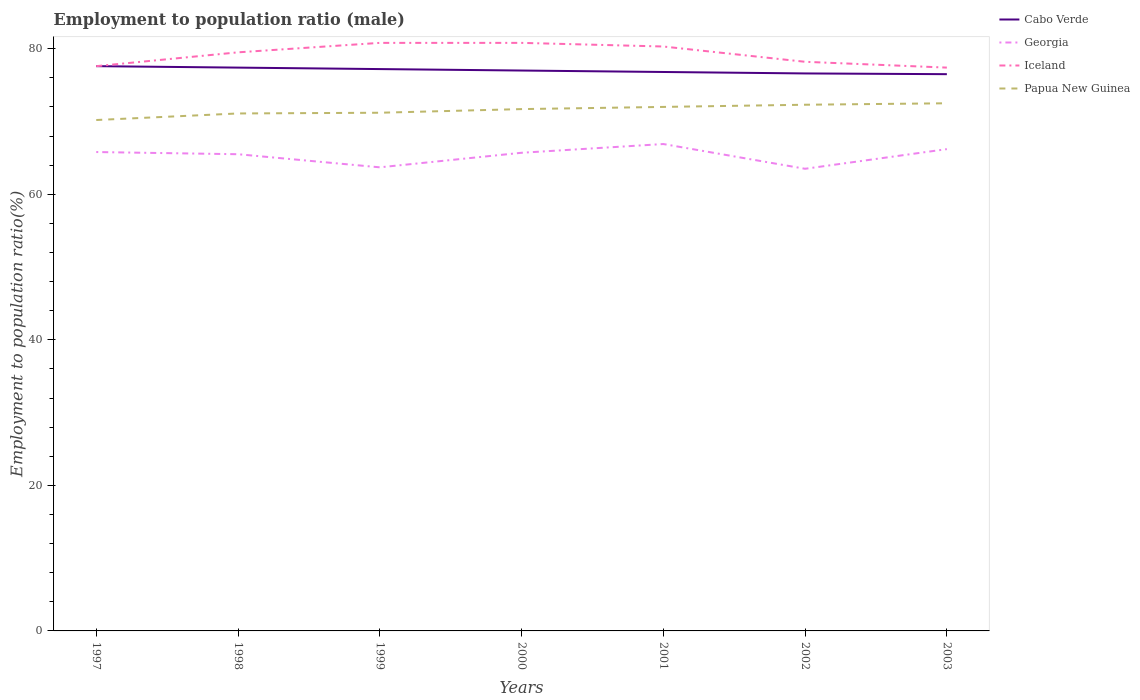How many different coloured lines are there?
Offer a terse response. 4. Across all years, what is the maximum employment to population ratio in Georgia?
Your response must be concise. 63.5. What is the total employment to population ratio in Iceland in the graph?
Your answer should be compact. 2.1. What is the difference between the highest and the second highest employment to population ratio in Iceland?
Offer a terse response. 3.4. Is the employment to population ratio in Iceland strictly greater than the employment to population ratio in Georgia over the years?
Keep it short and to the point. No. How many lines are there?
Keep it short and to the point. 4. Are the values on the major ticks of Y-axis written in scientific E-notation?
Give a very brief answer. No. Where does the legend appear in the graph?
Ensure brevity in your answer.  Top right. How are the legend labels stacked?
Give a very brief answer. Vertical. What is the title of the graph?
Offer a very short reply. Employment to population ratio (male). What is the Employment to population ratio(%) of Cabo Verde in 1997?
Provide a short and direct response. 77.6. What is the Employment to population ratio(%) of Georgia in 1997?
Provide a short and direct response. 65.8. What is the Employment to population ratio(%) of Iceland in 1997?
Offer a very short reply. 77.6. What is the Employment to population ratio(%) of Papua New Guinea in 1997?
Offer a terse response. 70.2. What is the Employment to population ratio(%) in Cabo Verde in 1998?
Your response must be concise. 77.4. What is the Employment to population ratio(%) of Georgia in 1998?
Offer a terse response. 65.5. What is the Employment to population ratio(%) of Iceland in 1998?
Provide a short and direct response. 79.5. What is the Employment to population ratio(%) in Papua New Guinea in 1998?
Your response must be concise. 71.1. What is the Employment to population ratio(%) of Cabo Verde in 1999?
Provide a short and direct response. 77.2. What is the Employment to population ratio(%) in Georgia in 1999?
Offer a terse response. 63.7. What is the Employment to population ratio(%) of Iceland in 1999?
Your answer should be very brief. 80.8. What is the Employment to population ratio(%) of Papua New Guinea in 1999?
Your answer should be very brief. 71.2. What is the Employment to population ratio(%) of Georgia in 2000?
Provide a succinct answer. 65.7. What is the Employment to population ratio(%) in Iceland in 2000?
Provide a succinct answer. 80.8. What is the Employment to population ratio(%) in Papua New Guinea in 2000?
Provide a succinct answer. 71.7. What is the Employment to population ratio(%) of Cabo Verde in 2001?
Give a very brief answer. 76.8. What is the Employment to population ratio(%) of Georgia in 2001?
Provide a short and direct response. 66.9. What is the Employment to population ratio(%) of Iceland in 2001?
Your answer should be very brief. 80.3. What is the Employment to population ratio(%) of Cabo Verde in 2002?
Provide a short and direct response. 76.6. What is the Employment to population ratio(%) of Georgia in 2002?
Ensure brevity in your answer.  63.5. What is the Employment to population ratio(%) in Iceland in 2002?
Your answer should be compact. 78.2. What is the Employment to population ratio(%) of Papua New Guinea in 2002?
Offer a terse response. 72.3. What is the Employment to population ratio(%) in Cabo Verde in 2003?
Offer a very short reply. 76.5. What is the Employment to population ratio(%) in Georgia in 2003?
Offer a terse response. 66.2. What is the Employment to population ratio(%) in Iceland in 2003?
Provide a succinct answer. 77.4. What is the Employment to population ratio(%) in Papua New Guinea in 2003?
Keep it short and to the point. 72.5. Across all years, what is the maximum Employment to population ratio(%) in Cabo Verde?
Provide a short and direct response. 77.6. Across all years, what is the maximum Employment to population ratio(%) of Georgia?
Keep it short and to the point. 66.9. Across all years, what is the maximum Employment to population ratio(%) of Iceland?
Offer a very short reply. 80.8. Across all years, what is the maximum Employment to population ratio(%) in Papua New Guinea?
Ensure brevity in your answer.  72.5. Across all years, what is the minimum Employment to population ratio(%) in Cabo Verde?
Keep it short and to the point. 76.5. Across all years, what is the minimum Employment to population ratio(%) in Georgia?
Offer a very short reply. 63.5. Across all years, what is the minimum Employment to population ratio(%) of Iceland?
Your response must be concise. 77.4. Across all years, what is the minimum Employment to population ratio(%) of Papua New Guinea?
Give a very brief answer. 70.2. What is the total Employment to population ratio(%) in Cabo Verde in the graph?
Ensure brevity in your answer.  539.1. What is the total Employment to population ratio(%) of Georgia in the graph?
Give a very brief answer. 457.3. What is the total Employment to population ratio(%) in Iceland in the graph?
Make the answer very short. 554.6. What is the total Employment to population ratio(%) in Papua New Guinea in the graph?
Offer a terse response. 501. What is the difference between the Employment to population ratio(%) in Cabo Verde in 1997 and that in 1998?
Your response must be concise. 0.2. What is the difference between the Employment to population ratio(%) of Georgia in 1997 and that in 1998?
Provide a short and direct response. 0.3. What is the difference between the Employment to population ratio(%) of Cabo Verde in 1997 and that in 1999?
Provide a short and direct response. 0.4. What is the difference between the Employment to population ratio(%) in Georgia in 1997 and that in 1999?
Your response must be concise. 2.1. What is the difference between the Employment to population ratio(%) in Georgia in 1997 and that in 2000?
Keep it short and to the point. 0.1. What is the difference between the Employment to population ratio(%) of Iceland in 1997 and that in 2000?
Provide a succinct answer. -3.2. What is the difference between the Employment to population ratio(%) in Cabo Verde in 1997 and that in 2001?
Make the answer very short. 0.8. What is the difference between the Employment to population ratio(%) in Georgia in 1997 and that in 2002?
Make the answer very short. 2.3. What is the difference between the Employment to population ratio(%) of Iceland in 1997 and that in 2002?
Your answer should be compact. -0.6. What is the difference between the Employment to population ratio(%) of Papua New Guinea in 1997 and that in 2002?
Offer a very short reply. -2.1. What is the difference between the Employment to population ratio(%) of Cabo Verde in 1997 and that in 2003?
Your answer should be compact. 1.1. What is the difference between the Employment to population ratio(%) of Iceland in 1997 and that in 2003?
Ensure brevity in your answer.  0.2. What is the difference between the Employment to population ratio(%) in Papua New Guinea in 1997 and that in 2003?
Offer a terse response. -2.3. What is the difference between the Employment to population ratio(%) of Papua New Guinea in 1998 and that in 1999?
Provide a succinct answer. -0.1. What is the difference between the Employment to population ratio(%) in Georgia in 1998 and that in 2000?
Offer a terse response. -0.2. What is the difference between the Employment to population ratio(%) of Iceland in 1998 and that in 2000?
Your answer should be compact. -1.3. What is the difference between the Employment to population ratio(%) in Papua New Guinea in 1998 and that in 2000?
Your response must be concise. -0.6. What is the difference between the Employment to population ratio(%) of Georgia in 1998 and that in 2001?
Ensure brevity in your answer.  -1.4. What is the difference between the Employment to population ratio(%) of Georgia in 1998 and that in 2002?
Make the answer very short. 2. What is the difference between the Employment to population ratio(%) in Iceland in 1998 and that in 2002?
Your answer should be compact. 1.3. What is the difference between the Employment to population ratio(%) in Papua New Guinea in 1998 and that in 2002?
Make the answer very short. -1.2. What is the difference between the Employment to population ratio(%) of Cabo Verde in 1998 and that in 2003?
Offer a very short reply. 0.9. What is the difference between the Employment to population ratio(%) in Georgia in 1998 and that in 2003?
Make the answer very short. -0.7. What is the difference between the Employment to population ratio(%) of Papua New Guinea in 1998 and that in 2003?
Make the answer very short. -1.4. What is the difference between the Employment to population ratio(%) of Cabo Verde in 1999 and that in 2000?
Provide a short and direct response. 0.2. What is the difference between the Employment to population ratio(%) in Iceland in 1999 and that in 2000?
Your answer should be compact. 0. What is the difference between the Employment to population ratio(%) of Georgia in 1999 and that in 2001?
Give a very brief answer. -3.2. What is the difference between the Employment to population ratio(%) of Iceland in 1999 and that in 2001?
Provide a short and direct response. 0.5. What is the difference between the Employment to population ratio(%) of Cabo Verde in 1999 and that in 2002?
Offer a terse response. 0.6. What is the difference between the Employment to population ratio(%) in Iceland in 1999 and that in 2002?
Your answer should be very brief. 2.6. What is the difference between the Employment to population ratio(%) of Papua New Guinea in 1999 and that in 2002?
Ensure brevity in your answer.  -1.1. What is the difference between the Employment to population ratio(%) in Cabo Verde in 1999 and that in 2003?
Your answer should be very brief. 0.7. What is the difference between the Employment to population ratio(%) of Georgia in 1999 and that in 2003?
Your answer should be compact. -2.5. What is the difference between the Employment to population ratio(%) of Iceland in 1999 and that in 2003?
Offer a terse response. 3.4. What is the difference between the Employment to population ratio(%) of Papua New Guinea in 1999 and that in 2003?
Your response must be concise. -1.3. What is the difference between the Employment to population ratio(%) of Georgia in 2000 and that in 2001?
Offer a very short reply. -1.2. What is the difference between the Employment to population ratio(%) of Cabo Verde in 2000 and that in 2002?
Offer a terse response. 0.4. What is the difference between the Employment to population ratio(%) of Georgia in 2000 and that in 2002?
Your response must be concise. 2.2. What is the difference between the Employment to population ratio(%) of Iceland in 2000 and that in 2002?
Provide a short and direct response. 2.6. What is the difference between the Employment to population ratio(%) in Papua New Guinea in 2000 and that in 2002?
Keep it short and to the point. -0.6. What is the difference between the Employment to population ratio(%) of Cabo Verde in 2000 and that in 2003?
Your answer should be compact. 0.5. What is the difference between the Employment to population ratio(%) in Iceland in 2000 and that in 2003?
Provide a succinct answer. 3.4. What is the difference between the Employment to population ratio(%) in Papua New Guinea in 2000 and that in 2003?
Keep it short and to the point. -0.8. What is the difference between the Employment to population ratio(%) in Cabo Verde in 2001 and that in 2002?
Offer a terse response. 0.2. What is the difference between the Employment to population ratio(%) of Georgia in 2001 and that in 2002?
Your response must be concise. 3.4. What is the difference between the Employment to population ratio(%) of Papua New Guinea in 2001 and that in 2002?
Give a very brief answer. -0.3. What is the difference between the Employment to population ratio(%) of Cabo Verde in 2001 and that in 2003?
Provide a succinct answer. 0.3. What is the difference between the Employment to population ratio(%) in Georgia in 2001 and that in 2003?
Your response must be concise. 0.7. What is the difference between the Employment to population ratio(%) in Iceland in 2001 and that in 2003?
Provide a short and direct response. 2.9. What is the difference between the Employment to population ratio(%) of Papua New Guinea in 2001 and that in 2003?
Ensure brevity in your answer.  -0.5. What is the difference between the Employment to population ratio(%) of Georgia in 2002 and that in 2003?
Provide a succinct answer. -2.7. What is the difference between the Employment to population ratio(%) of Papua New Guinea in 2002 and that in 2003?
Offer a terse response. -0.2. What is the difference between the Employment to population ratio(%) of Georgia in 1997 and the Employment to population ratio(%) of Iceland in 1998?
Your answer should be compact. -13.7. What is the difference between the Employment to population ratio(%) in Georgia in 1997 and the Employment to population ratio(%) in Papua New Guinea in 1998?
Give a very brief answer. -5.3. What is the difference between the Employment to population ratio(%) of Iceland in 1997 and the Employment to population ratio(%) of Papua New Guinea in 1998?
Provide a short and direct response. 6.5. What is the difference between the Employment to population ratio(%) in Cabo Verde in 1997 and the Employment to population ratio(%) in Iceland in 1999?
Your answer should be compact. -3.2. What is the difference between the Employment to population ratio(%) of Georgia in 1997 and the Employment to population ratio(%) of Iceland in 1999?
Give a very brief answer. -15. What is the difference between the Employment to population ratio(%) of Cabo Verde in 1997 and the Employment to population ratio(%) of Georgia in 2000?
Make the answer very short. 11.9. What is the difference between the Employment to population ratio(%) in Cabo Verde in 1997 and the Employment to population ratio(%) in Iceland in 2000?
Offer a very short reply. -3.2. What is the difference between the Employment to population ratio(%) in Cabo Verde in 1997 and the Employment to population ratio(%) in Papua New Guinea in 2000?
Ensure brevity in your answer.  5.9. What is the difference between the Employment to population ratio(%) of Georgia in 1997 and the Employment to population ratio(%) of Iceland in 2000?
Ensure brevity in your answer.  -15. What is the difference between the Employment to population ratio(%) in Georgia in 1997 and the Employment to population ratio(%) in Papua New Guinea in 2000?
Your response must be concise. -5.9. What is the difference between the Employment to population ratio(%) of Cabo Verde in 1997 and the Employment to population ratio(%) of Iceland in 2002?
Offer a terse response. -0.6. What is the difference between the Employment to population ratio(%) in Cabo Verde in 1997 and the Employment to population ratio(%) in Papua New Guinea in 2002?
Your response must be concise. 5.3. What is the difference between the Employment to population ratio(%) in Georgia in 1997 and the Employment to population ratio(%) in Iceland in 2002?
Offer a terse response. -12.4. What is the difference between the Employment to population ratio(%) in Georgia in 1997 and the Employment to population ratio(%) in Papua New Guinea in 2002?
Give a very brief answer. -6.5. What is the difference between the Employment to population ratio(%) of Iceland in 1997 and the Employment to population ratio(%) of Papua New Guinea in 2002?
Make the answer very short. 5.3. What is the difference between the Employment to population ratio(%) in Cabo Verde in 1997 and the Employment to population ratio(%) in Georgia in 2003?
Make the answer very short. 11.4. What is the difference between the Employment to population ratio(%) in Cabo Verde in 1997 and the Employment to population ratio(%) in Iceland in 2003?
Ensure brevity in your answer.  0.2. What is the difference between the Employment to population ratio(%) in Cabo Verde in 1997 and the Employment to population ratio(%) in Papua New Guinea in 2003?
Provide a succinct answer. 5.1. What is the difference between the Employment to population ratio(%) in Georgia in 1997 and the Employment to population ratio(%) in Papua New Guinea in 2003?
Offer a terse response. -6.7. What is the difference between the Employment to population ratio(%) of Cabo Verde in 1998 and the Employment to population ratio(%) of Georgia in 1999?
Your answer should be compact. 13.7. What is the difference between the Employment to population ratio(%) of Georgia in 1998 and the Employment to population ratio(%) of Iceland in 1999?
Offer a very short reply. -15.3. What is the difference between the Employment to population ratio(%) in Georgia in 1998 and the Employment to population ratio(%) in Papua New Guinea in 1999?
Your answer should be compact. -5.7. What is the difference between the Employment to population ratio(%) of Cabo Verde in 1998 and the Employment to population ratio(%) of Iceland in 2000?
Ensure brevity in your answer.  -3.4. What is the difference between the Employment to population ratio(%) in Georgia in 1998 and the Employment to population ratio(%) in Iceland in 2000?
Provide a short and direct response. -15.3. What is the difference between the Employment to population ratio(%) in Iceland in 1998 and the Employment to population ratio(%) in Papua New Guinea in 2000?
Keep it short and to the point. 7.8. What is the difference between the Employment to population ratio(%) in Cabo Verde in 1998 and the Employment to population ratio(%) in Georgia in 2001?
Offer a terse response. 10.5. What is the difference between the Employment to population ratio(%) of Cabo Verde in 1998 and the Employment to population ratio(%) of Papua New Guinea in 2001?
Keep it short and to the point. 5.4. What is the difference between the Employment to population ratio(%) in Georgia in 1998 and the Employment to population ratio(%) in Iceland in 2001?
Your answer should be compact. -14.8. What is the difference between the Employment to population ratio(%) of Georgia in 1998 and the Employment to population ratio(%) of Papua New Guinea in 2001?
Make the answer very short. -6.5. What is the difference between the Employment to population ratio(%) of Iceland in 1998 and the Employment to population ratio(%) of Papua New Guinea in 2001?
Offer a terse response. 7.5. What is the difference between the Employment to population ratio(%) in Cabo Verde in 1998 and the Employment to population ratio(%) in Georgia in 2002?
Provide a short and direct response. 13.9. What is the difference between the Employment to population ratio(%) of Cabo Verde in 1998 and the Employment to population ratio(%) of Papua New Guinea in 2002?
Your answer should be very brief. 5.1. What is the difference between the Employment to population ratio(%) of Georgia in 1998 and the Employment to population ratio(%) of Iceland in 2002?
Offer a terse response. -12.7. What is the difference between the Employment to population ratio(%) in Cabo Verde in 1998 and the Employment to population ratio(%) in Georgia in 2003?
Offer a very short reply. 11.2. What is the difference between the Employment to population ratio(%) of Cabo Verde in 1998 and the Employment to population ratio(%) of Papua New Guinea in 2003?
Offer a terse response. 4.9. What is the difference between the Employment to population ratio(%) in Georgia in 1998 and the Employment to population ratio(%) in Iceland in 2003?
Keep it short and to the point. -11.9. What is the difference between the Employment to population ratio(%) of Georgia in 1998 and the Employment to population ratio(%) of Papua New Guinea in 2003?
Your response must be concise. -7. What is the difference between the Employment to population ratio(%) in Cabo Verde in 1999 and the Employment to population ratio(%) in Iceland in 2000?
Offer a very short reply. -3.6. What is the difference between the Employment to population ratio(%) of Georgia in 1999 and the Employment to population ratio(%) of Iceland in 2000?
Offer a very short reply. -17.1. What is the difference between the Employment to population ratio(%) in Cabo Verde in 1999 and the Employment to population ratio(%) in Georgia in 2001?
Ensure brevity in your answer.  10.3. What is the difference between the Employment to population ratio(%) in Cabo Verde in 1999 and the Employment to population ratio(%) in Iceland in 2001?
Your response must be concise. -3.1. What is the difference between the Employment to population ratio(%) of Georgia in 1999 and the Employment to population ratio(%) of Iceland in 2001?
Give a very brief answer. -16.6. What is the difference between the Employment to population ratio(%) of Iceland in 1999 and the Employment to population ratio(%) of Papua New Guinea in 2001?
Provide a succinct answer. 8.8. What is the difference between the Employment to population ratio(%) in Cabo Verde in 1999 and the Employment to population ratio(%) in Papua New Guinea in 2002?
Keep it short and to the point. 4.9. What is the difference between the Employment to population ratio(%) of Georgia in 1999 and the Employment to population ratio(%) of Iceland in 2003?
Your answer should be compact. -13.7. What is the difference between the Employment to population ratio(%) of Georgia in 2000 and the Employment to population ratio(%) of Iceland in 2001?
Your answer should be very brief. -14.6. What is the difference between the Employment to population ratio(%) of Georgia in 2000 and the Employment to population ratio(%) of Papua New Guinea in 2001?
Your response must be concise. -6.3. What is the difference between the Employment to population ratio(%) in Iceland in 2000 and the Employment to population ratio(%) in Papua New Guinea in 2001?
Make the answer very short. 8.8. What is the difference between the Employment to population ratio(%) of Cabo Verde in 2000 and the Employment to population ratio(%) of Iceland in 2002?
Give a very brief answer. -1.2. What is the difference between the Employment to population ratio(%) of Cabo Verde in 2000 and the Employment to population ratio(%) of Papua New Guinea in 2002?
Keep it short and to the point. 4.7. What is the difference between the Employment to population ratio(%) of Iceland in 2000 and the Employment to population ratio(%) of Papua New Guinea in 2002?
Your answer should be very brief. 8.5. What is the difference between the Employment to population ratio(%) in Cabo Verde in 2000 and the Employment to population ratio(%) in Georgia in 2003?
Give a very brief answer. 10.8. What is the difference between the Employment to population ratio(%) in Cabo Verde in 2000 and the Employment to population ratio(%) in Iceland in 2003?
Ensure brevity in your answer.  -0.4. What is the difference between the Employment to population ratio(%) in Iceland in 2000 and the Employment to population ratio(%) in Papua New Guinea in 2003?
Provide a short and direct response. 8.3. What is the difference between the Employment to population ratio(%) of Cabo Verde in 2001 and the Employment to population ratio(%) of Iceland in 2002?
Provide a short and direct response. -1.4. What is the difference between the Employment to population ratio(%) of Georgia in 2001 and the Employment to population ratio(%) of Papua New Guinea in 2002?
Ensure brevity in your answer.  -5.4. What is the difference between the Employment to population ratio(%) of Georgia in 2001 and the Employment to population ratio(%) of Iceland in 2003?
Give a very brief answer. -10.5. What is the difference between the Employment to population ratio(%) of Cabo Verde in 2002 and the Employment to population ratio(%) of Georgia in 2003?
Your answer should be compact. 10.4. What is the difference between the Employment to population ratio(%) of Georgia in 2002 and the Employment to population ratio(%) of Iceland in 2003?
Your answer should be compact. -13.9. What is the difference between the Employment to population ratio(%) in Georgia in 2002 and the Employment to population ratio(%) in Papua New Guinea in 2003?
Your response must be concise. -9. What is the difference between the Employment to population ratio(%) of Iceland in 2002 and the Employment to population ratio(%) of Papua New Guinea in 2003?
Give a very brief answer. 5.7. What is the average Employment to population ratio(%) of Cabo Verde per year?
Give a very brief answer. 77.01. What is the average Employment to population ratio(%) of Georgia per year?
Your answer should be very brief. 65.33. What is the average Employment to population ratio(%) of Iceland per year?
Give a very brief answer. 79.23. What is the average Employment to population ratio(%) in Papua New Guinea per year?
Your answer should be compact. 71.57. In the year 1997, what is the difference between the Employment to population ratio(%) in Cabo Verde and Employment to population ratio(%) in Iceland?
Make the answer very short. 0. In the year 1997, what is the difference between the Employment to population ratio(%) in Georgia and Employment to population ratio(%) in Iceland?
Provide a short and direct response. -11.8. In the year 1997, what is the difference between the Employment to population ratio(%) of Iceland and Employment to population ratio(%) of Papua New Guinea?
Your answer should be compact. 7.4. In the year 1998, what is the difference between the Employment to population ratio(%) of Cabo Verde and Employment to population ratio(%) of Georgia?
Give a very brief answer. 11.9. In the year 1998, what is the difference between the Employment to population ratio(%) in Cabo Verde and Employment to population ratio(%) in Iceland?
Offer a terse response. -2.1. In the year 1999, what is the difference between the Employment to population ratio(%) of Cabo Verde and Employment to population ratio(%) of Papua New Guinea?
Offer a very short reply. 6. In the year 1999, what is the difference between the Employment to population ratio(%) in Georgia and Employment to population ratio(%) in Iceland?
Your answer should be compact. -17.1. In the year 2000, what is the difference between the Employment to population ratio(%) of Cabo Verde and Employment to population ratio(%) of Georgia?
Your response must be concise. 11.3. In the year 2000, what is the difference between the Employment to population ratio(%) of Cabo Verde and Employment to population ratio(%) of Iceland?
Offer a terse response. -3.8. In the year 2000, what is the difference between the Employment to population ratio(%) of Georgia and Employment to population ratio(%) of Iceland?
Keep it short and to the point. -15.1. In the year 2000, what is the difference between the Employment to population ratio(%) of Iceland and Employment to population ratio(%) of Papua New Guinea?
Give a very brief answer. 9.1. In the year 2001, what is the difference between the Employment to population ratio(%) of Cabo Verde and Employment to population ratio(%) of Iceland?
Offer a very short reply. -3.5. In the year 2002, what is the difference between the Employment to population ratio(%) in Cabo Verde and Employment to population ratio(%) in Georgia?
Your response must be concise. 13.1. In the year 2002, what is the difference between the Employment to population ratio(%) in Cabo Verde and Employment to population ratio(%) in Iceland?
Offer a very short reply. -1.6. In the year 2002, what is the difference between the Employment to population ratio(%) in Cabo Verde and Employment to population ratio(%) in Papua New Guinea?
Give a very brief answer. 4.3. In the year 2002, what is the difference between the Employment to population ratio(%) of Georgia and Employment to population ratio(%) of Iceland?
Keep it short and to the point. -14.7. In the year 2003, what is the difference between the Employment to population ratio(%) in Georgia and Employment to population ratio(%) in Iceland?
Your answer should be very brief. -11.2. In the year 2003, what is the difference between the Employment to population ratio(%) in Georgia and Employment to population ratio(%) in Papua New Guinea?
Ensure brevity in your answer.  -6.3. What is the ratio of the Employment to population ratio(%) of Iceland in 1997 to that in 1998?
Offer a terse response. 0.98. What is the ratio of the Employment to population ratio(%) of Papua New Guinea in 1997 to that in 1998?
Your answer should be very brief. 0.99. What is the ratio of the Employment to population ratio(%) of Cabo Verde in 1997 to that in 1999?
Ensure brevity in your answer.  1.01. What is the ratio of the Employment to population ratio(%) of Georgia in 1997 to that in 1999?
Your response must be concise. 1.03. What is the ratio of the Employment to population ratio(%) in Iceland in 1997 to that in 1999?
Your response must be concise. 0.96. What is the ratio of the Employment to population ratio(%) of Papua New Guinea in 1997 to that in 1999?
Keep it short and to the point. 0.99. What is the ratio of the Employment to population ratio(%) of Cabo Verde in 1997 to that in 2000?
Your answer should be very brief. 1.01. What is the ratio of the Employment to population ratio(%) of Georgia in 1997 to that in 2000?
Keep it short and to the point. 1. What is the ratio of the Employment to population ratio(%) in Iceland in 1997 to that in 2000?
Offer a very short reply. 0.96. What is the ratio of the Employment to population ratio(%) in Papua New Guinea in 1997 to that in 2000?
Offer a very short reply. 0.98. What is the ratio of the Employment to population ratio(%) of Cabo Verde in 1997 to that in 2001?
Your answer should be very brief. 1.01. What is the ratio of the Employment to population ratio(%) in Georgia in 1997 to that in 2001?
Provide a succinct answer. 0.98. What is the ratio of the Employment to population ratio(%) of Iceland in 1997 to that in 2001?
Make the answer very short. 0.97. What is the ratio of the Employment to population ratio(%) in Cabo Verde in 1997 to that in 2002?
Keep it short and to the point. 1.01. What is the ratio of the Employment to population ratio(%) in Georgia in 1997 to that in 2002?
Provide a short and direct response. 1.04. What is the ratio of the Employment to population ratio(%) of Iceland in 1997 to that in 2002?
Ensure brevity in your answer.  0.99. What is the ratio of the Employment to population ratio(%) in Cabo Verde in 1997 to that in 2003?
Give a very brief answer. 1.01. What is the ratio of the Employment to population ratio(%) of Iceland in 1997 to that in 2003?
Ensure brevity in your answer.  1. What is the ratio of the Employment to population ratio(%) of Papua New Guinea in 1997 to that in 2003?
Give a very brief answer. 0.97. What is the ratio of the Employment to population ratio(%) of Cabo Verde in 1998 to that in 1999?
Your answer should be compact. 1. What is the ratio of the Employment to population ratio(%) in Georgia in 1998 to that in 1999?
Provide a short and direct response. 1.03. What is the ratio of the Employment to population ratio(%) of Iceland in 1998 to that in 1999?
Make the answer very short. 0.98. What is the ratio of the Employment to population ratio(%) of Papua New Guinea in 1998 to that in 1999?
Your answer should be very brief. 1. What is the ratio of the Employment to population ratio(%) in Iceland in 1998 to that in 2000?
Provide a short and direct response. 0.98. What is the ratio of the Employment to population ratio(%) of Cabo Verde in 1998 to that in 2001?
Give a very brief answer. 1.01. What is the ratio of the Employment to population ratio(%) of Georgia in 1998 to that in 2001?
Provide a short and direct response. 0.98. What is the ratio of the Employment to population ratio(%) of Papua New Guinea in 1998 to that in 2001?
Keep it short and to the point. 0.99. What is the ratio of the Employment to population ratio(%) in Cabo Verde in 1998 to that in 2002?
Your answer should be very brief. 1.01. What is the ratio of the Employment to population ratio(%) in Georgia in 1998 to that in 2002?
Provide a short and direct response. 1.03. What is the ratio of the Employment to population ratio(%) in Iceland in 1998 to that in 2002?
Offer a terse response. 1.02. What is the ratio of the Employment to population ratio(%) in Papua New Guinea in 1998 to that in 2002?
Your response must be concise. 0.98. What is the ratio of the Employment to population ratio(%) in Cabo Verde in 1998 to that in 2003?
Provide a short and direct response. 1.01. What is the ratio of the Employment to population ratio(%) of Georgia in 1998 to that in 2003?
Provide a succinct answer. 0.99. What is the ratio of the Employment to population ratio(%) of Iceland in 1998 to that in 2003?
Provide a short and direct response. 1.03. What is the ratio of the Employment to population ratio(%) in Papua New Guinea in 1998 to that in 2003?
Provide a succinct answer. 0.98. What is the ratio of the Employment to population ratio(%) of Georgia in 1999 to that in 2000?
Your response must be concise. 0.97. What is the ratio of the Employment to population ratio(%) in Papua New Guinea in 1999 to that in 2000?
Your answer should be very brief. 0.99. What is the ratio of the Employment to population ratio(%) of Georgia in 1999 to that in 2001?
Offer a terse response. 0.95. What is the ratio of the Employment to population ratio(%) in Papua New Guinea in 1999 to that in 2001?
Your answer should be compact. 0.99. What is the ratio of the Employment to population ratio(%) in Georgia in 1999 to that in 2002?
Keep it short and to the point. 1. What is the ratio of the Employment to population ratio(%) of Iceland in 1999 to that in 2002?
Your response must be concise. 1.03. What is the ratio of the Employment to population ratio(%) in Papua New Guinea in 1999 to that in 2002?
Your response must be concise. 0.98. What is the ratio of the Employment to population ratio(%) in Cabo Verde in 1999 to that in 2003?
Make the answer very short. 1.01. What is the ratio of the Employment to population ratio(%) of Georgia in 1999 to that in 2003?
Offer a very short reply. 0.96. What is the ratio of the Employment to population ratio(%) of Iceland in 1999 to that in 2003?
Offer a terse response. 1.04. What is the ratio of the Employment to population ratio(%) in Papua New Guinea in 1999 to that in 2003?
Ensure brevity in your answer.  0.98. What is the ratio of the Employment to population ratio(%) of Cabo Verde in 2000 to that in 2001?
Ensure brevity in your answer.  1. What is the ratio of the Employment to population ratio(%) of Georgia in 2000 to that in 2001?
Provide a succinct answer. 0.98. What is the ratio of the Employment to population ratio(%) of Papua New Guinea in 2000 to that in 2001?
Make the answer very short. 1. What is the ratio of the Employment to population ratio(%) of Georgia in 2000 to that in 2002?
Your answer should be very brief. 1.03. What is the ratio of the Employment to population ratio(%) of Iceland in 2000 to that in 2002?
Ensure brevity in your answer.  1.03. What is the ratio of the Employment to population ratio(%) of Papua New Guinea in 2000 to that in 2002?
Your response must be concise. 0.99. What is the ratio of the Employment to population ratio(%) in Georgia in 2000 to that in 2003?
Ensure brevity in your answer.  0.99. What is the ratio of the Employment to population ratio(%) of Iceland in 2000 to that in 2003?
Your answer should be very brief. 1.04. What is the ratio of the Employment to population ratio(%) of Georgia in 2001 to that in 2002?
Keep it short and to the point. 1.05. What is the ratio of the Employment to population ratio(%) of Iceland in 2001 to that in 2002?
Ensure brevity in your answer.  1.03. What is the ratio of the Employment to population ratio(%) of Georgia in 2001 to that in 2003?
Keep it short and to the point. 1.01. What is the ratio of the Employment to population ratio(%) in Iceland in 2001 to that in 2003?
Your answer should be compact. 1.04. What is the ratio of the Employment to population ratio(%) in Cabo Verde in 2002 to that in 2003?
Offer a very short reply. 1. What is the ratio of the Employment to population ratio(%) of Georgia in 2002 to that in 2003?
Your response must be concise. 0.96. What is the ratio of the Employment to population ratio(%) in Iceland in 2002 to that in 2003?
Offer a very short reply. 1.01. What is the ratio of the Employment to population ratio(%) in Papua New Guinea in 2002 to that in 2003?
Keep it short and to the point. 1. What is the difference between the highest and the second highest Employment to population ratio(%) of Cabo Verde?
Provide a succinct answer. 0.2. What is the difference between the highest and the second highest Employment to population ratio(%) of Iceland?
Provide a short and direct response. 0. What is the difference between the highest and the lowest Employment to population ratio(%) in Iceland?
Ensure brevity in your answer.  3.4. 